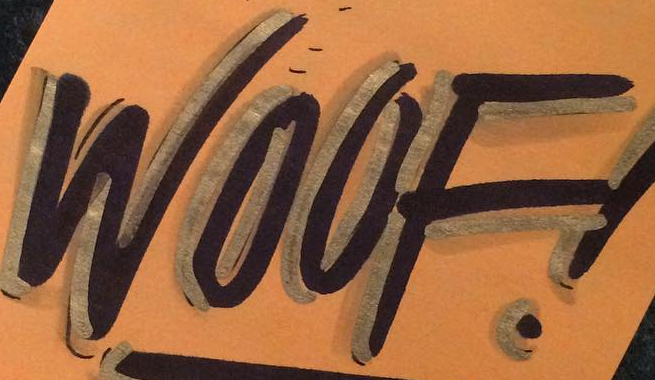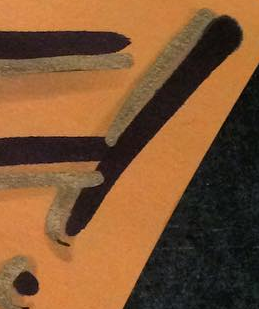Identify the words shown in these images in order, separated by a semicolon. WOOF; ! 